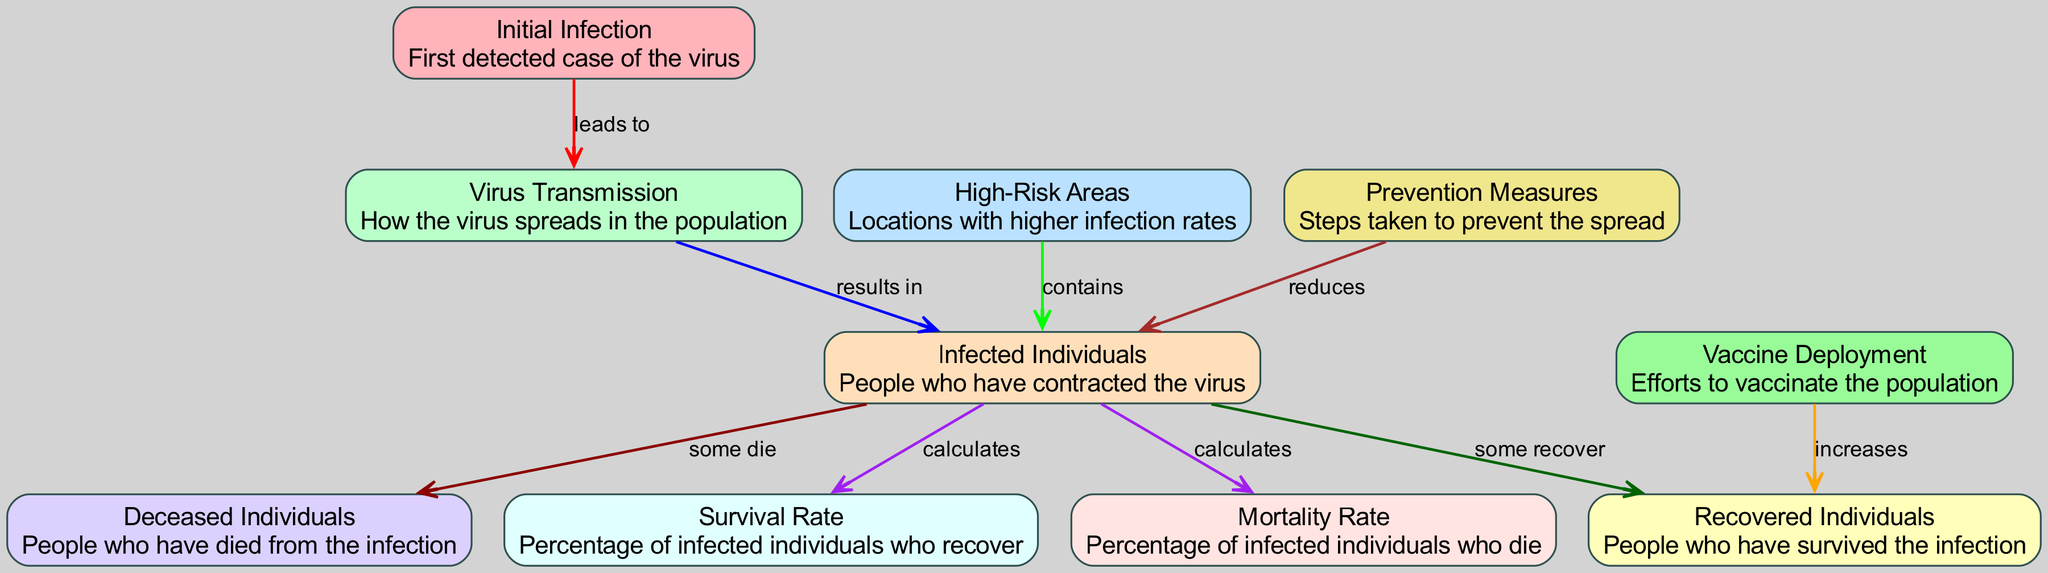What is the first detected case of the virus? The diagram identifies "Initial Infection" as the first detected case, as it's the starting point of the flow in the diagram.
Answer: Initial Infection What is the relationship between "Virus Transmission" and "Infected Individuals"? The diagram shows that "Virus Transmission" results in "Infected Individuals," indicating that the act of spreading leads to people contracting the virus.
Answer: results in How many nodes are present in the diagram? By counting all the listed nodes in the data, there are a total of 10 nodes representing different aspects of the viral outbreak.
Answer: 10 What percentage of infected individuals recover based on the survival rate? The node labeled "Survival Rate" provides the percentage of infected individuals who recover as calculated in the diagram.
Answer: Survival Rate Which node describes actions taken to prevent the spread? The diagram has a node labeled "Prevention Measures" that describes the steps taken to mitigate the outbreak.
Answer: Prevention Measures What do "High-Risk Areas" contain according to the diagram? The diagram indicates that "High-Risk Areas" contain "Infected Individuals," demonstrating that these areas have a higher concentration of infections.
Answer: contain How do "Vaccine Deployment" efforts impact "Recovered Individuals"? The diagram illustrates that "Vaccine Deployment" increases the number of "Recovered Individuals," suggesting a positive effect of vaccination on recovery rates.
Answer: increases What percentage is associated with the "Mortality Rate"? The node labeled "Mortality Rate" determines the percentage of infected individuals who die from the virus, as indicated in the diagram.
Answer: Mortality Rate What is the consequence of "Infected Individuals" as depicted in the diagram? The diagram indicates that "Infected Individuals" leads to two consequences: some recover and some die, illustrating the outcomes of the infection.
Answer: some recover, some die What measures reduce the number of "Infected Individuals"? According to the diagram, "Prevention Measures" reduce the number of "Infected Individuals," showing the effectiveness of actions taken to control the virus spread.
Answer: reduces 